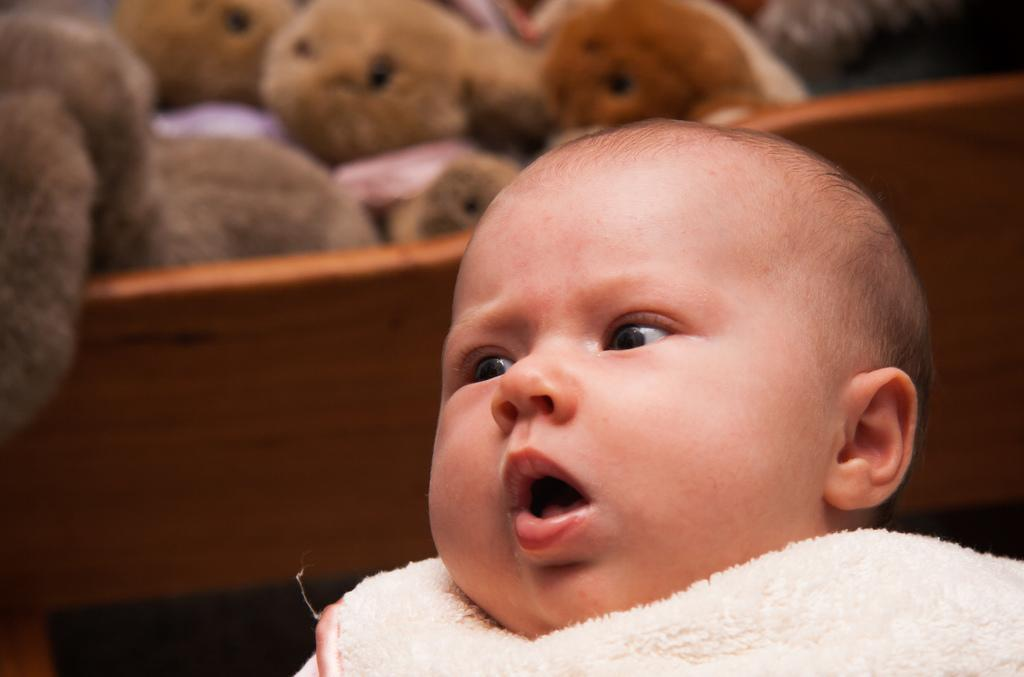What is the main subject in the foreground of the image? There is a baby in the foreground of the image. What can be seen in the background of the image? There is a bed in the background of the image. What is on the bed? There are toys on the bed. What type of potato is being used as a pillow for the baby in the image? There is no potato present in the image, and the baby is not using a potato as a pillow. 